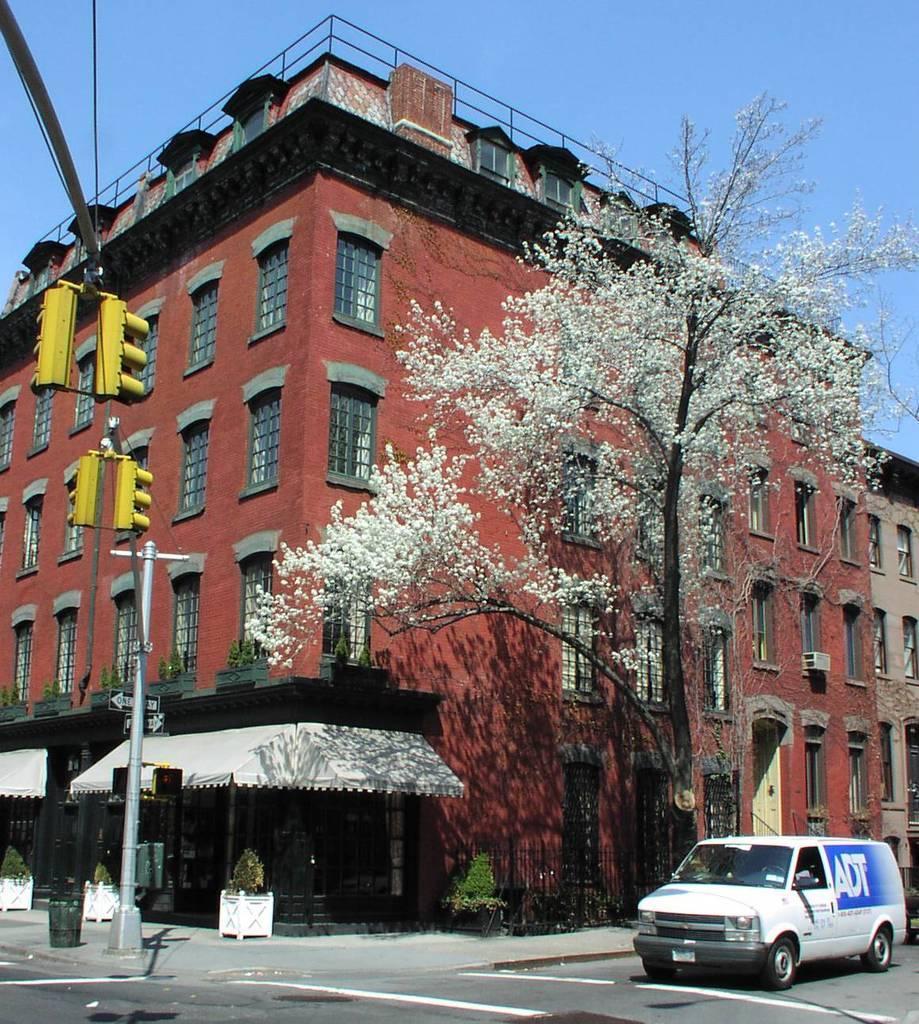In one or two sentences, can you explain what this image depicts? In this image there is a building, trees, plants, signal lights, poles, vehicle, railing, sky and objects. 